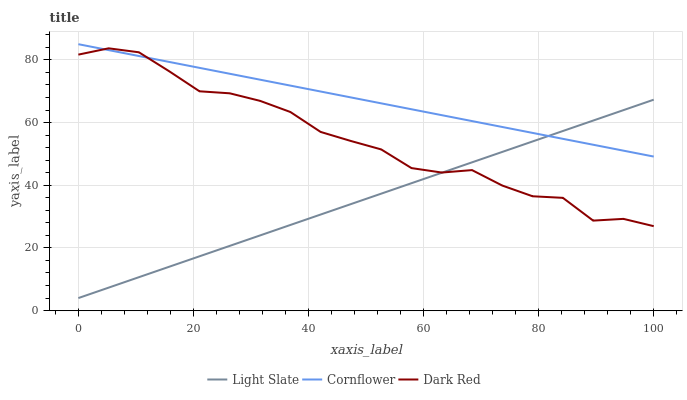Does Light Slate have the minimum area under the curve?
Answer yes or no. Yes. Does Cornflower have the maximum area under the curve?
Answer yes or no. Yes. Does Dark Red have the minimum area under the curve?
Answer yes or no. No. Does Dark Red have the maximum area under the curve?
Answer yes or no. No. Is Light Slate the smoothest?
Answer yes or no. Yes. Is Dark Red the roughest?
Answer yes or no. Yes. Is Cornflower the smoothest?
Answer yes or no. No. Is Cornflower the roughest?
Answer yes or no. No. Does Light Slate have the lowest value?
Answer yes or no. Yes. Does Dark Red have the lowest value?
Answer yes or no. No. Does Cornflower have the highest value?
Answer yes or no. Yes. Does Dark Red have the highest value?
Answer yes or no. No. Does Light Slate intersect Dark Red?
Answer yes or no. Yes. Is Light Slate less than Dark Red?
Answer yes or no. No. Is Light Slate greater than Dark Red?
Answer yes or no. No. 